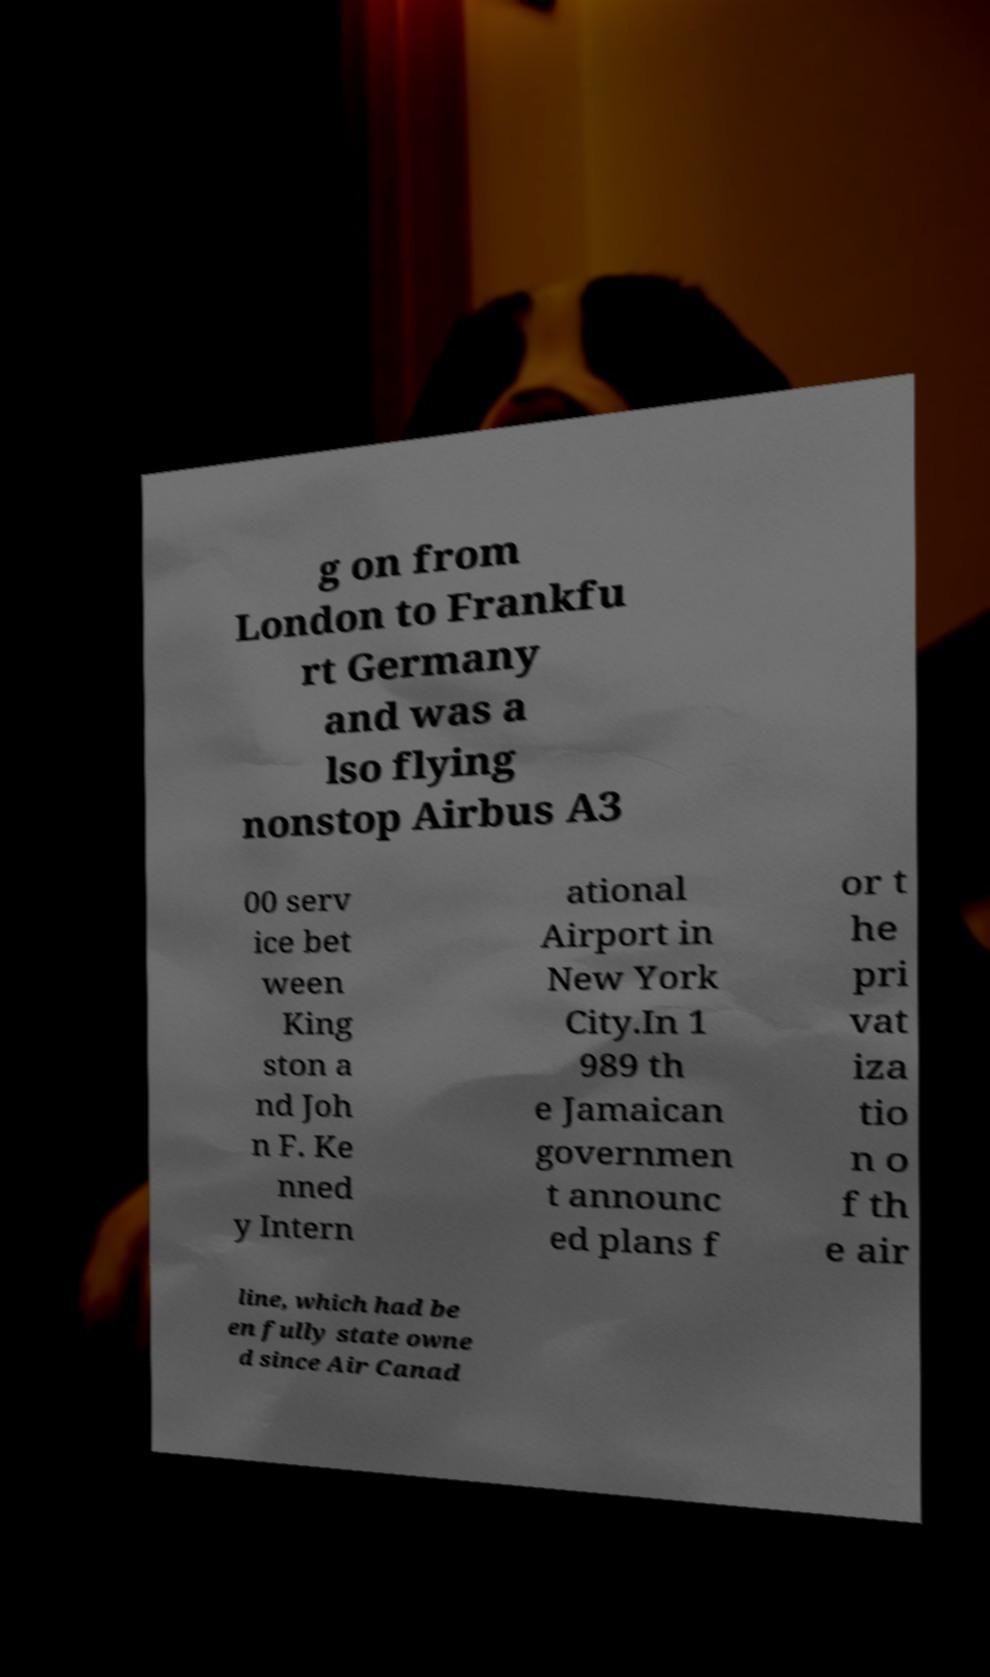Can you accurately transcribe the text from the provided image for me? g on from London to Frankfu rt Germany and was a lso flying nonstop Airbus A3 00 serv ice bet ween King ston a nd Joh n F. Ke nned y Intern ational Airport in New York City.In 1 989 th e Jamaican governmen t announc ed plans f or t he pri vat iza tio n o f th e air line, which had be en fully state owne d since Air Canad 